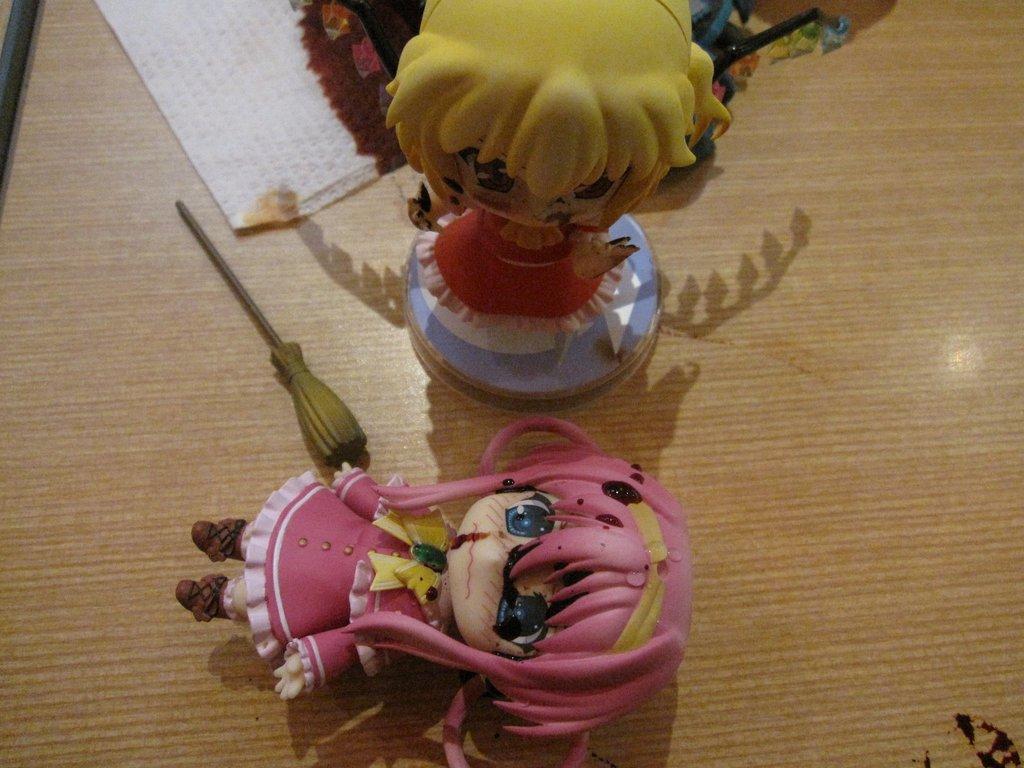Describe this image in one or two sentences. In this image we can see doll toys which are on the wooden surface. 